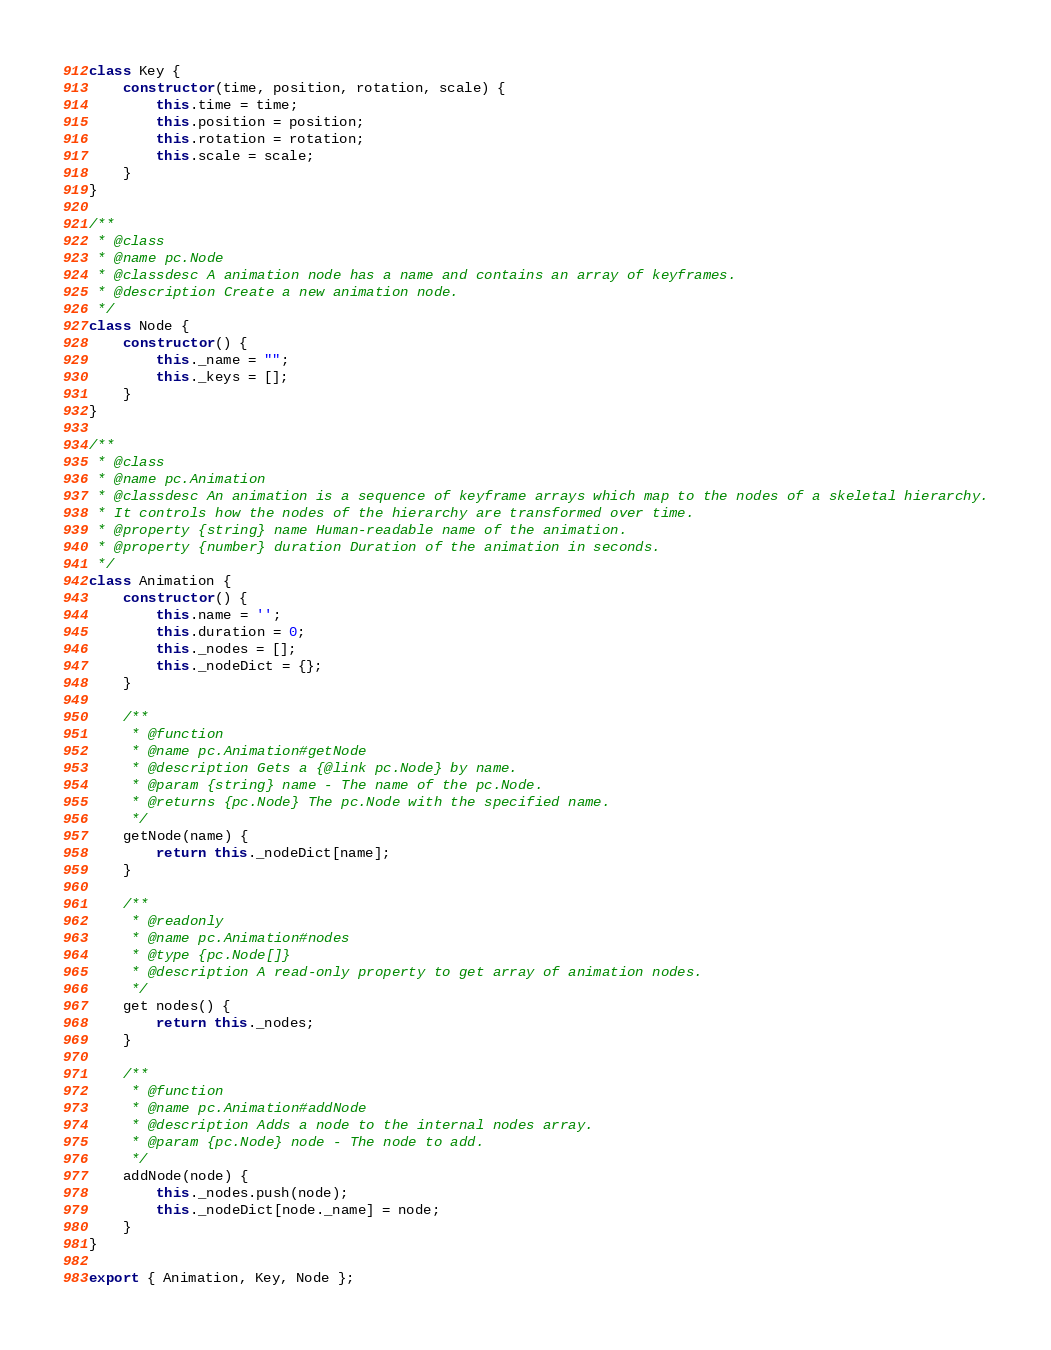Convert code to text. <code><loc_0><loc_0><loc_500><loc_500><_JavaScript_>class Key {
    constructor(time, position, rotation, scale) {
        this.time = time;
        this.position = position;
        this.rotation = rotation;
        this.scale = scale;
    }
}

/**
 * @class
 * @name pc.Node
 * @classdesc A animation node has a name and contains an array of keyframes.
 * @description Create a new animation node.
 */
class Node {
    constructor() {
        this._name = "";
        this._keys = [];
    }
}

/**
 * @class
 * @name pc.Animation
 * @classdesc An animation is a sequence of keyframe arrays which map to the nodes of a skeletal hierarchy.
 * It controls how the nodes of the hierarchy are transformed over time.
 * @property {string} name Human-readable name of the animation.
 * @property {number} duration Duration of the animation in seconds.
 */
class Animation {
    constructor() {
        this.name = '';
        this.duration = 0;
        this._nodes = [];
        this._nodeDict = {};
    }

    /**
     * @function
     * @name pc.Animation#getNode
     * @description Gets a {@link pc.Node} by name.
     * @param {string} name - The name of the pc.Node.
     * @returns {pc.Node} The pc.Node with the specified name.
     */
    getNode(name) {
        return this._nodeDict[name];
    }

    /**
     * @readonly
     * @name pc.Animation#nodes
     * @type {pc.Node[]}
     * @description A read-only property to get array of animation nodes.
     */
    get nodes() {
        return this._nodes;
    }

    /**
     * @function
     * @name pc.Animation#addNode
     * @description Adds a node to the internal nodes array.
     * @param {pc.Node} node - The node to add.
     */
    addNode(node) {
        this._nodes.push(node);
        this._nodeDict[node._name] = node;
    }
}

export { Animation, Key, Node };
</code> 